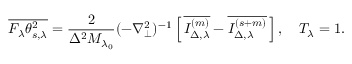<formula> <loc_0><loc_0><loc_500><loc_500>\overline { { F _ { \lambda } \theta _ { s , \lambda } ^ { 2 } } } = \frac { 2 } { \Delta ^ { 2 } M _ { \lambda _ { 0 } } } ( - \nabla _ { \perp } ^ { 2 } ) ^ { - 1 } \left [ \, \overline { { I _ { \Delta , \lambda } ^ { ( m ) } } } - \overline { { I _ { \Delta , \lambda } ^ { ( s + m ) } } } \, \right ] , \quad T _ { \lambda } = 1 .</formula> 